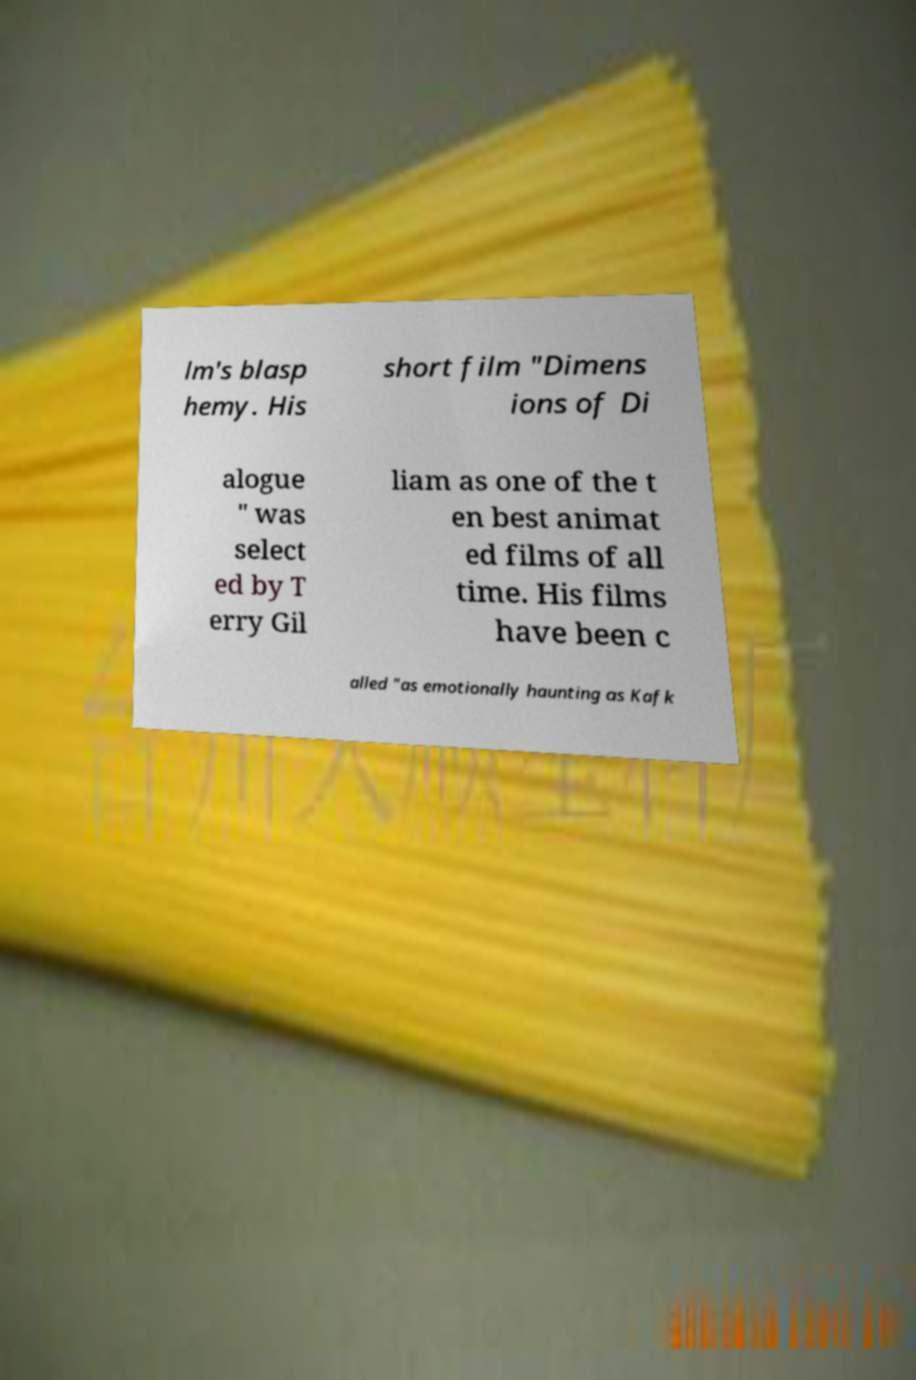What messages or text are displayed in this image? I need them in a readable, typed format. lm's blasp hemy. His short film "Dimens ions of Di alogue " was select ed by T erry Gil liam as one of the t en best animat ed films of all time. His films have been c alled "as emotionally haunting as Kafk 